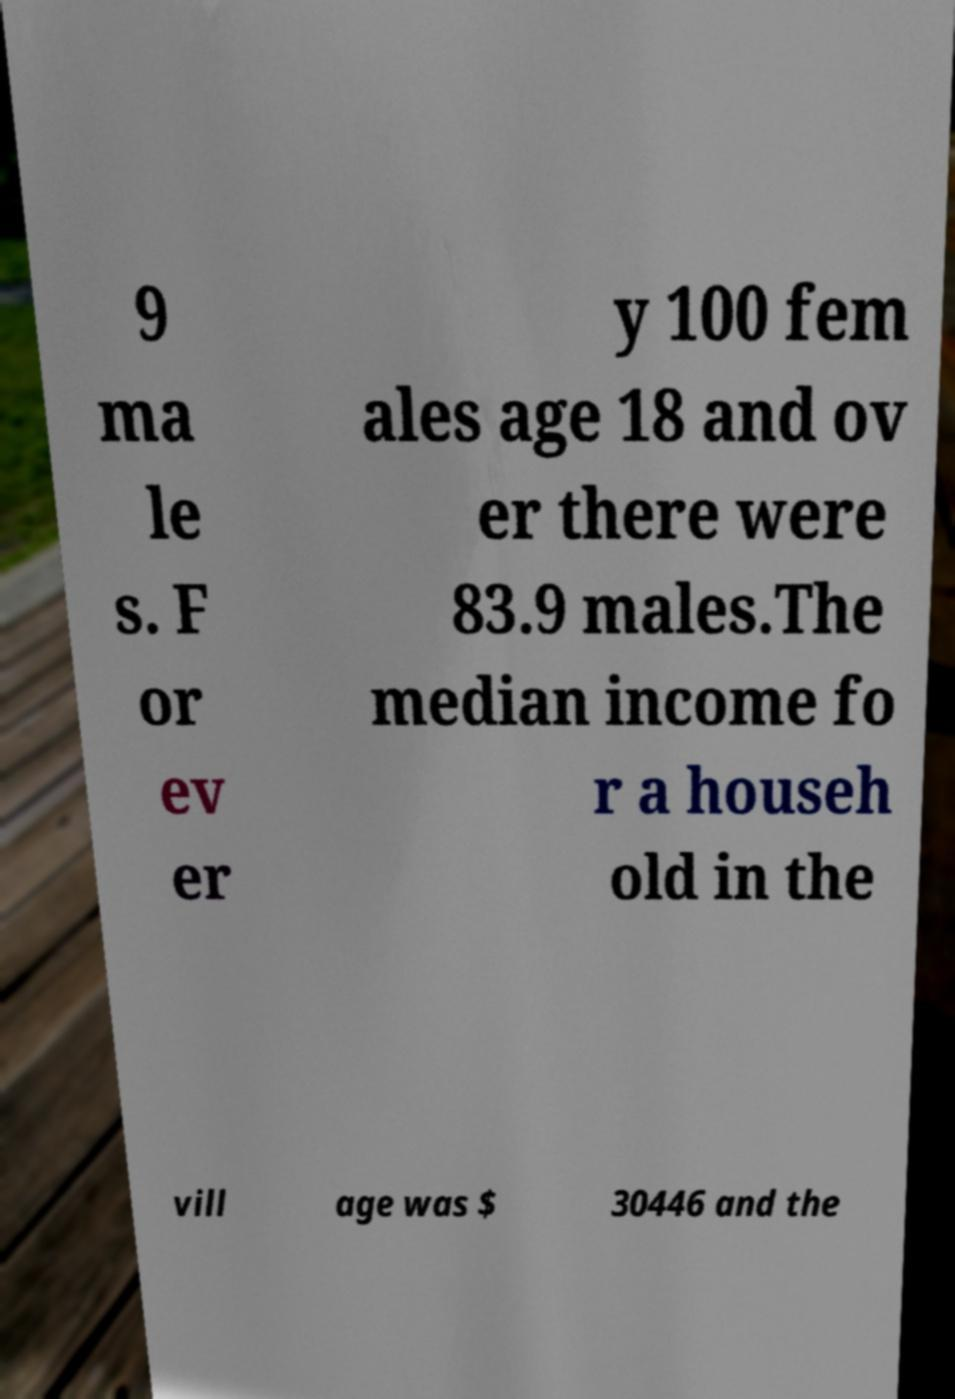Could you assist in decoding the text presented in this image and type it out clearly? 9 ma le s. F or ev er y 100 fem ales age 18 and ov er there were 83.9 males.The median income fo r a househ old in the vill age was $ 30446 and the 